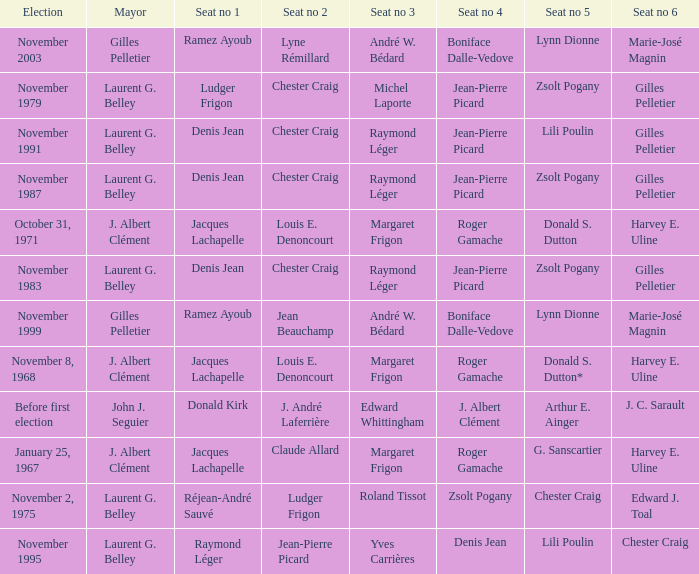Who is seat no 1 when the mayor was john j. seguier Donald Kirk. 